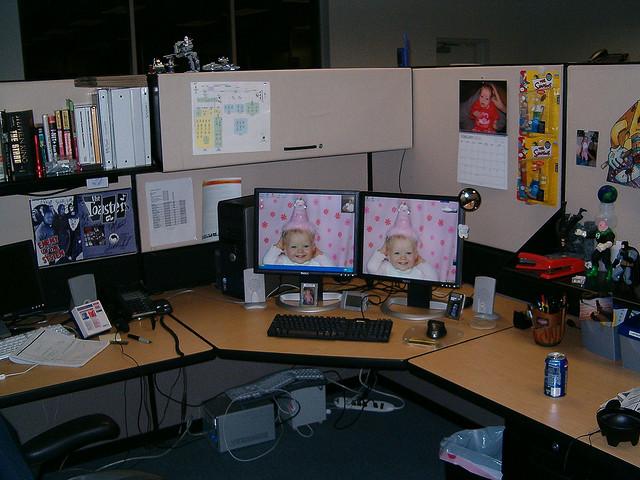Are the computers on?
Keep it brief. Yes. What objects are black and white striped in the background?
Short answer required. Calendar. What object in this picture is pink?
Be succinct. Baby. What color is the desk?
Answer briefly. Brown. How many keyboards are there?
Answer briefly. 1. Are the 2 pictures of the baby the same?
Keep it brief. Yes. Is there a calendar on the wall?
Keep it brief. Yes. What are sitting on the floor to the far left?
Quick response, please. Desk chair. How many computer monitors?
Be succinct. 2. Is there  a baby in the life of the owner of this desk?
Concise answer only. Yes. The picture on the far right of the cubicle is meant to represent which famous artist's work?
Write a very short answer. Picasso. 